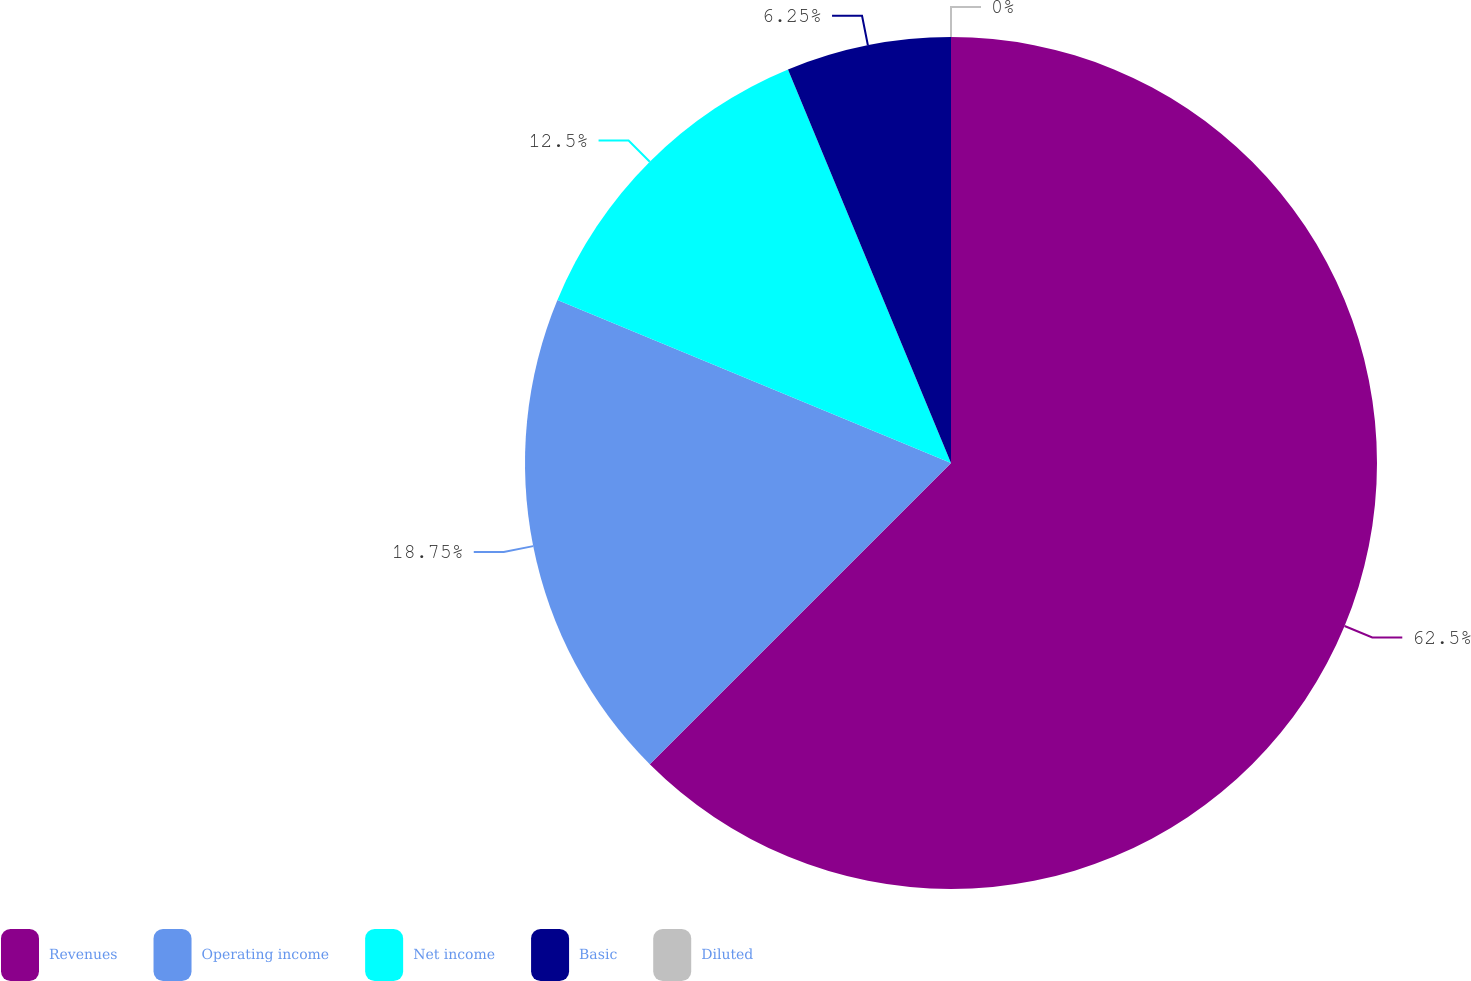<chart> <loc_0><loc_0><loc_500><loc_500><pie_chart><fcel>Revenues<fcel>Operating income<fcel>Net income<fcel>Basic<fcel>Diluted<nl><fcel>62.5%<fcel>18.75%<fcel>12.5%<fcel>6.25%<fcel>0.0%<nl></chart> 